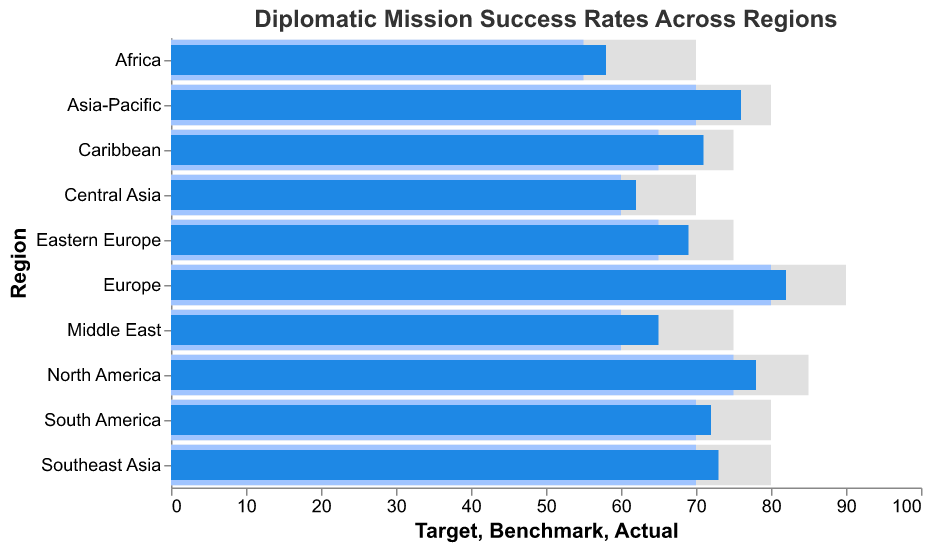How many regions have their actual success rate above the benchmark? By looking at the bullet chart, count the number of regions where the "Actual" bar (blue) extends beyond the "Benchmark" bar (light blue).
Answer: 10 Which region has the highest actual success rate? Identify the region with the longest blue bar indicating the "Actual" success rate.
Answer: Europe What is the average target success rate for all regions? Add up all the target values and divide by the number of regions: (85 + 90 + 80 + 75 + 70 + 80 + 75 + 80 + 70 + 75) / 10 = 780 / 10.
Answer: 78 Which region has the lowest benchmark success rate? Identify the region with the shortest light blue bar indicating the "Benchmark" success rate.
Answer: Africa How much higher is the benchmark rate for Europe compared to Africa? Subtract the benchmark value for Africa (55) from the benchmark value for Europe (80): 80 - 55.
Answer: 25 Did the actual success rate for the Middle East meet the target? Compare the blue bar ("Actual" value of 65) with the gray bar ("Target" value of 75).
Answer: No Which regions have an actual success rate below their target? Identify regions where the blue bar ("Actual") is shorter than the gray bar ("Target"): North America, Europe, Asia-Pacific, Middle East, Africa, South America, Southeast Asia, Central Asia, Caribbean.
Answer: 9 regions What is the difference between the actual success rates of South America and Southeast Asia? Subtract the "Actual" value of Southeast Asia (73) from South America (72): 72 - 73.
Answer: -1 How does the actual success rate of the Caribbean compare to its benchmark and target? Compare the blue bar indicating Actual (71) with the light blue bar Benchmark (65) and the gray bar Target (75). The actual success rate is 6 points above the benchmark and 4 points below the target.
Answer: Above the benchmark, below the target 